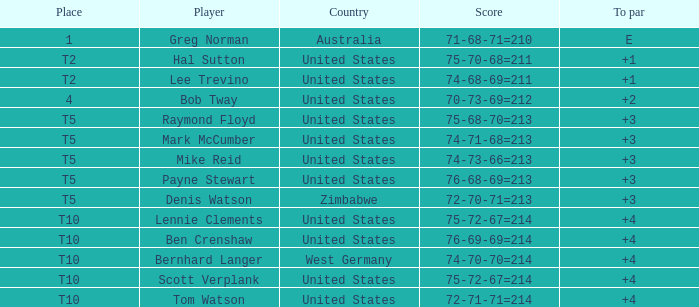Who is the player from the United States with a 75-70-68=211 score? Hal Sutton. Give me the full table as a dictionary. {'header': ['Place', 'Player', 'Country', 'Score', 'To par'], 'rows': [['1', 'Greg Norman', 'Australia', '71-68-71=210', 'E'], ['T2', 'Hal Sutton', 'United States', '75-70-68=211', '+1'], ['T2', 'Lee Trevino', 'United States', '74-68-69=211', '+1'], ['4', 'Bob Tway', 'United States', '70-73-69=212', '+2'], ['T5', 'Raymond Floyd', 'United States', '75-68-70=213', '+3'], ['T5', 'Mark McCumber', 'United States', '74-71-68=213', '+3'], ['T5', 'Mike Reid', 'United States', '74-73-66=213', '+3'], ['T5', 'Payne Stewart', 'United States', '76-68-69=213', '+3'], ['T5', 'Denis Watson', 'Zimbabwe', '72-70-71=213', '+3'], ['T10', 'Lennie Clements', 'United States', '75-72-67=214', '+4'], ['T10', 'Ben Crenshaw', 'United States', '76-69-69=214', '+4'], ['T10', 'Bernhard Langer', 'West Germany', '74-70-70=214', '+4'], ['T10', 'Scott Verplank', 'United States', '75-72-67=214', '+4'], ['T10', 'Tom Watson', 'United States', '72-71-71=214', '+4']]} 